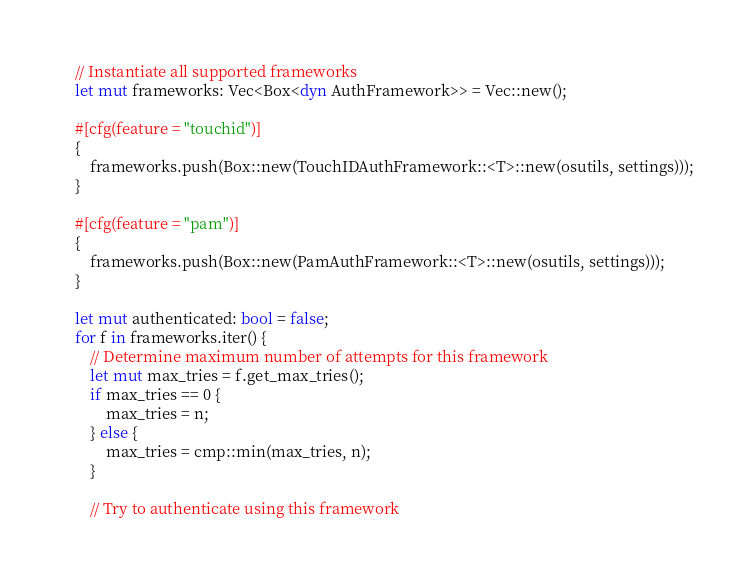<code> <loc_0><loc_0><loc_500><loc_500><_Rust_>    // Instantiate all supported frameworks
    let mut frameworks: Vec<Box<dyn AuthFramework>> = Vec::new();
    
    #[cfg(feature = "touchid")]
    {
        frameworks.push(Box::new(TouchIDAuthFramework::<T>::new(osutils, settings)));
    }
    
    #[cfg(feature = "pam")]
    {
        frameworks.push(Box::new(PamAuthFramework::<T>::new(osutils, settings)));
    } 

    let mut authenticated: bool = false;
    for f in frameworks.iter() {
        // Determine maximum number of attempts for this framework
        let mut max_tries = f.get_max_tries();
        if max_tries == 0 {
            max_tries = n;
        } else {
            max_tries = cmp::min(max_tries, n);
        }

        // Try to authenticate using this framework</code> 